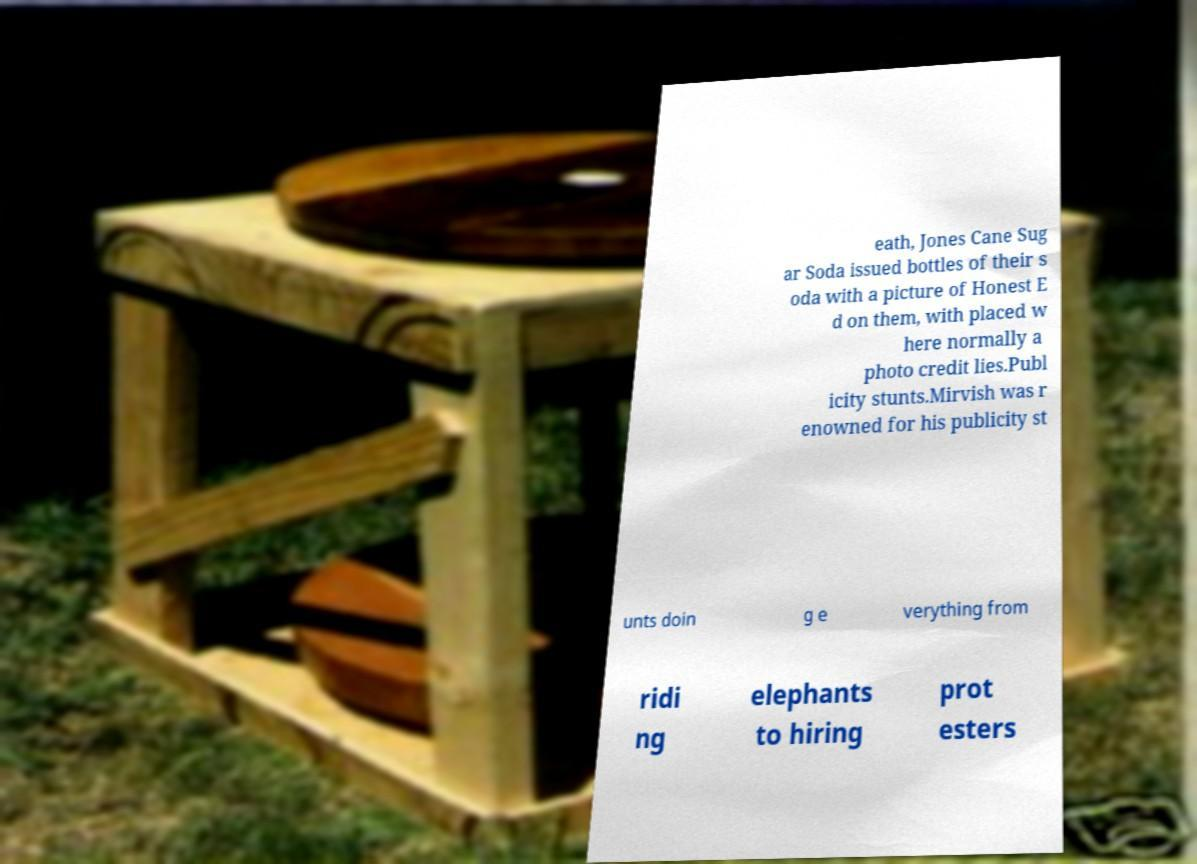Can you accurately transcribe the text from the provided image for me? eath, Jones Cane Sug ar Soda issued bottles of their s oda with a picture of Honest E d on them, with placed w here normally a photo credit lies.Publ icity stunts.Mirvish was r enowned for his publicity st unts doin g e verything from ridi ng elephants to hiring prot esters 